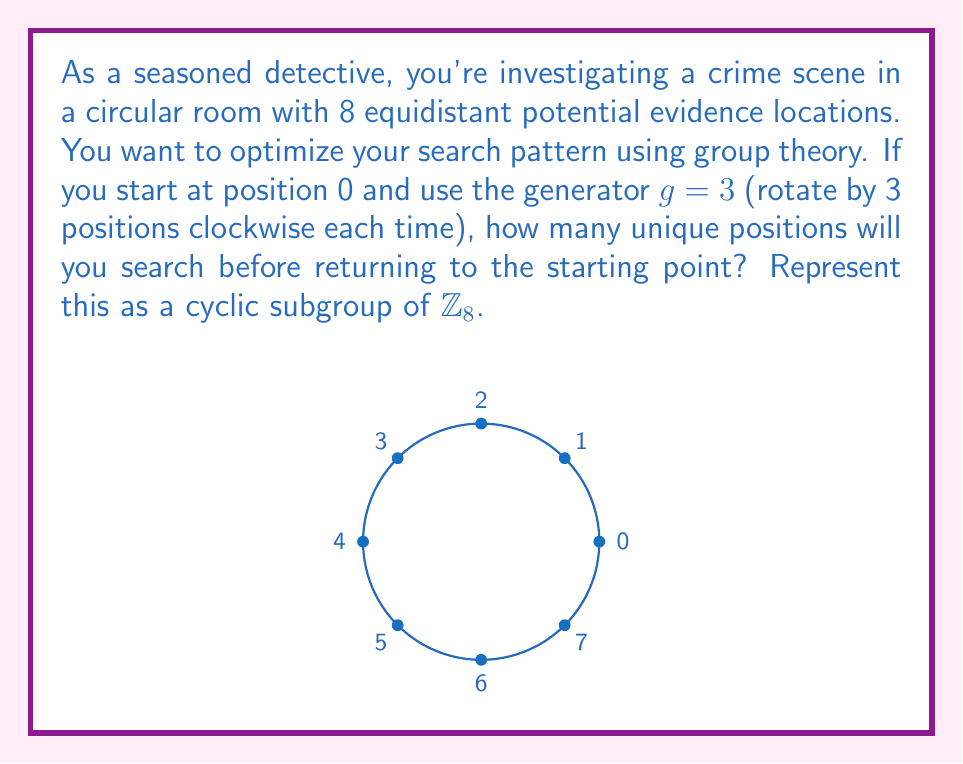Can you answer this question? Let's approach this step-by-step using group theory:

1) We're working with the cyclic group $\mathbb{Z}_8$, which represents the 8 positions in the room.

2) Our generator is $g = 3$, meaning we rotate by 3 positions each time.

3) To find the subgroup generated by $g$, we compute the powers of $g$ modulo 8:

   $g^1 = 3 \pmod{8}$
   $g^2 = 6 \pmod{8}$
   $g^3 = 1 \pmod{8}$
   $g^4 = 4 \pmod{8}$
   $g^5 = 7 \pmod{8}$
   $g^6 = 2 \pmod{8}$
   $g^7 = 5 \pmod{8}$
   $g^8 = 0 \pmod{8}$

4) We see that after 8 applications of $g$, we return to the starting point (0).

5) The subgroup generated by $g$ is $\langle g \rangle = \{0, 3, 6, 1, 4, 7, 2, 5\}$.

6) This subgroup has order 8, which is the same as the order of $\mathbb{Z}_8$.

7) Therefore, the generator $g = 3$ generates the entire group, and all 8 positions will be searched before returning to the starting point.

The cyclic subgroup can be represented as:

$$\langle 3 \rangle = \{0, 3, 6, 1, 4, 7, 2, 5\} \cong \mathbb{Z}_8$$
Answer: 8 positions; $\langle 3 \rangle \cong \mathbb{Z}_8$ 